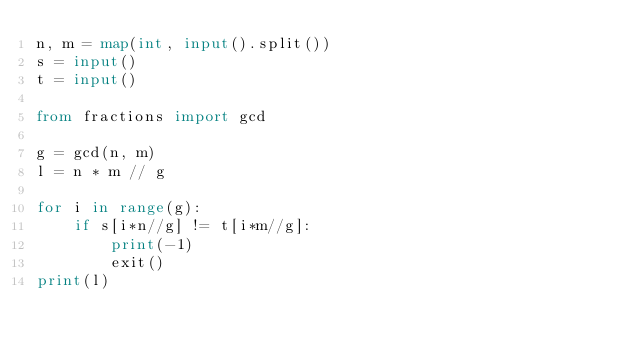Convert code to text. <code><loc_0><loc_0><loc_500><loc_500><_Python_>n, m = map(int, input().split())
s = input()
t = input()

from fractions import gcd

g = gcd(n, m)
l = n * m // g

for i in range(g):
    if s[i*n//g] != t[i*m//g]:
        print(-1)
        exit()
print(l)</code> 